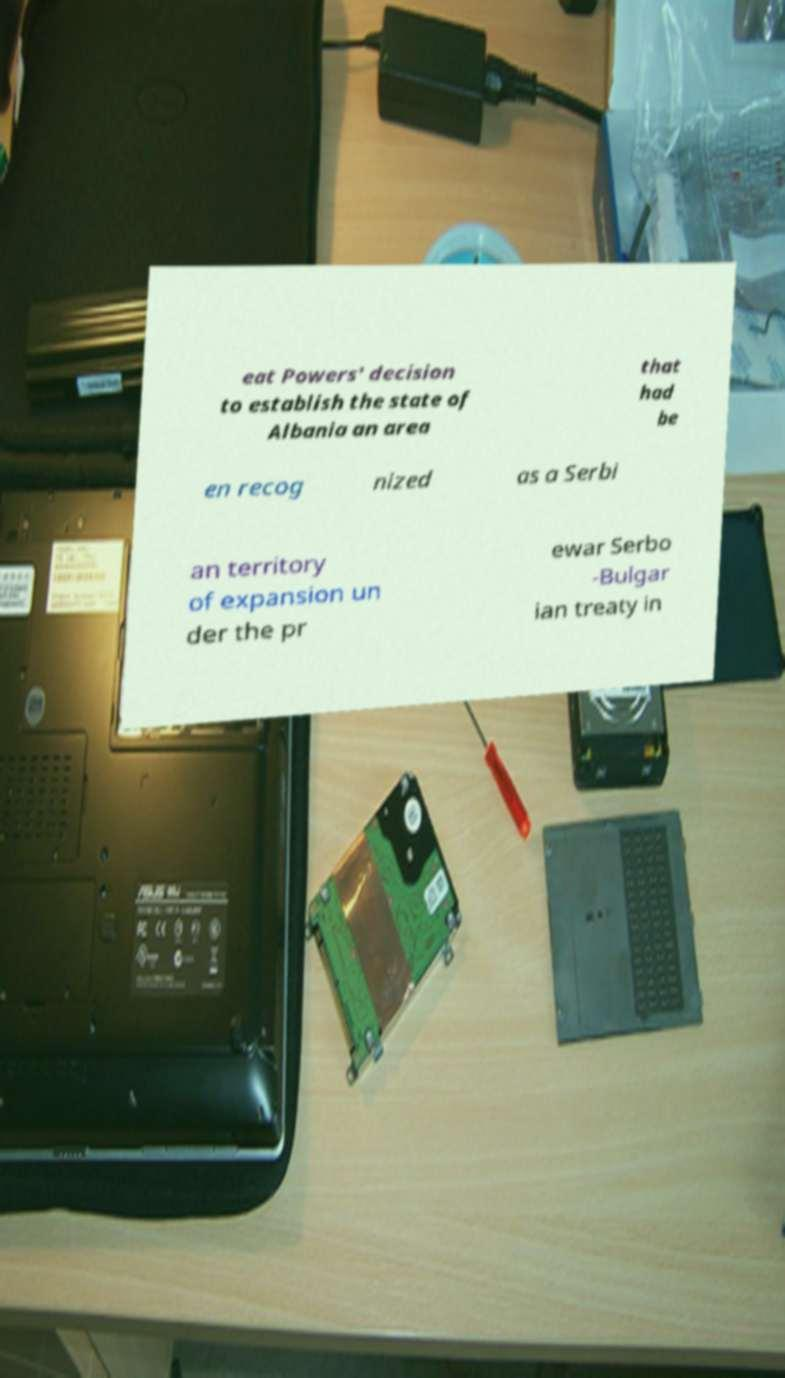Can you accurately transcribe the text from the provided image for me? eat Powers' decision to establish the state of Albania an area that had be en recog nized as a Serbi an territory of expansion un der the pr ewar Serbo -Bulgar ian treaty in 